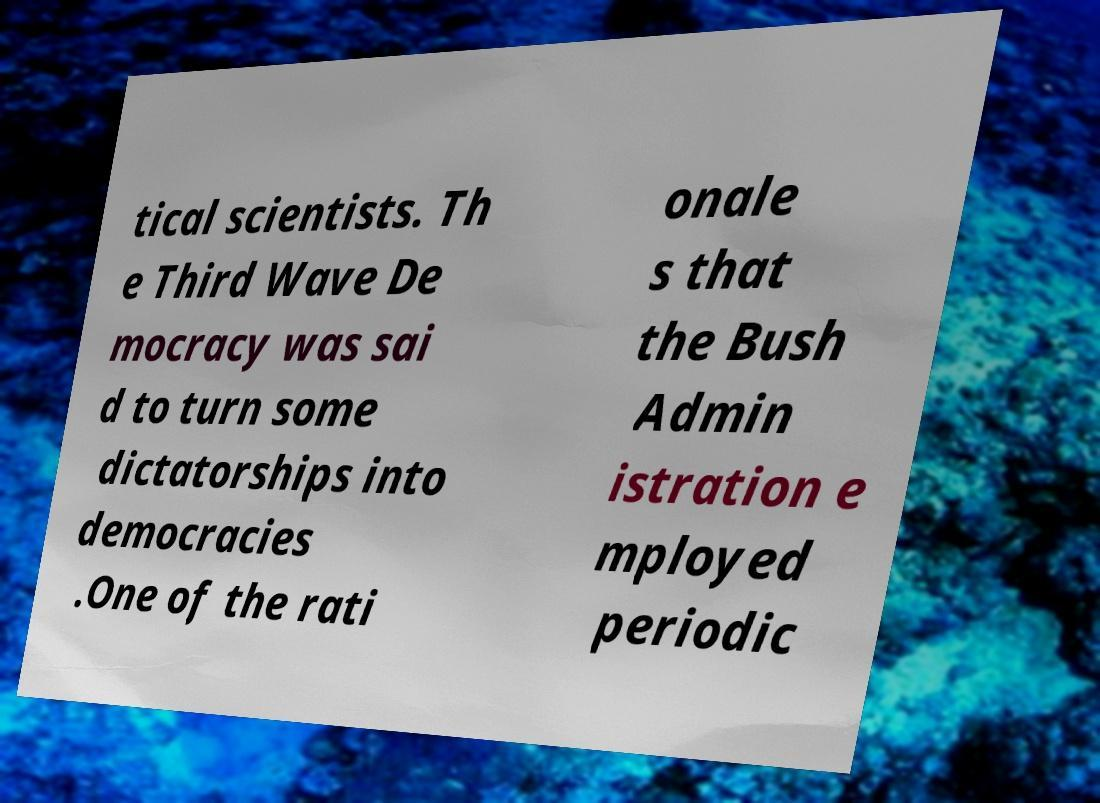I need the written content from this picture converted into text. Can you do that? tical scientists. Th e Third Wave De mocracy was sai d to turn some dictatorships into democracies .One of the rati onale s that the Bush Admin istration e mployed periodic 